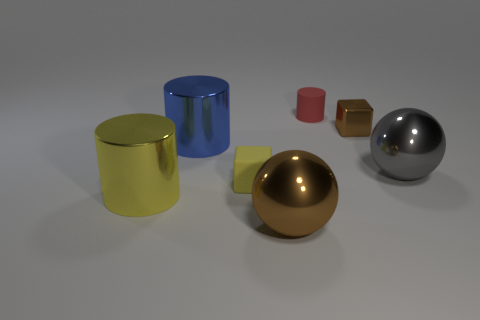Add 3 cyan blocks. How many objects exist? 10 Subtract all spheres. How many objects are left? 5 Add 4 tiny yellow things. How many tiny yellow things are left? 5 Add 2 tiny things. How many tiny things exist? 5 Subtract 0 green cubes. How many objects are left? 7 Subtract all spheres. Subtract all cyan metal cubes. How many objects are left? 5 